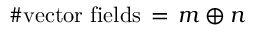Convert formula to latex. <formula><loc_0><loc_0><loc_500><loc_500>\# v e c t o r f i e l d s \, = \, m \oplus n</formula> 